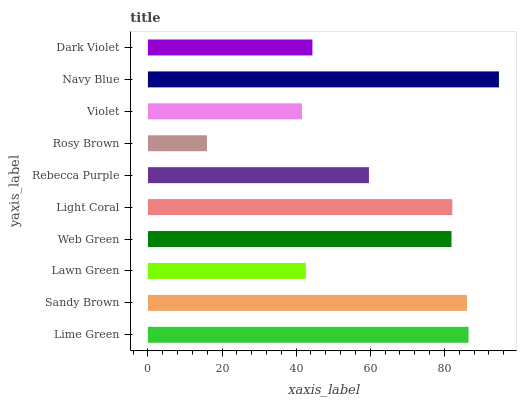Is Rosy Brown the minimum?
Answer yes or no. Yes. Is Navy Blue the maximum?
Answer yes or no. Yes. Is Sandy Brown the minimum?
Answer yes or no. No. Is Sandy Brown the maximum?
Answer yes or no. No. Is Lime Green greater than Sandy Brown?
Answer yes or no. Yes. Is Sandy Brown less than Lime Green?
Answer yes or no. Yes. Is Sandy Brown greater than Lime Green?
Answer yes or no. No. Is Lime Green less than Sandy Brown?
Answer yes or no. No. Is Web Green the high median?
Answer yes or no. Yes. Is Rebecca Purple the low median?
Answer yes or no. Yes. Is Light Coral the high median?
Answer yes or no. No. Is Lawn Green the low median?
Answer yes or no. No. 